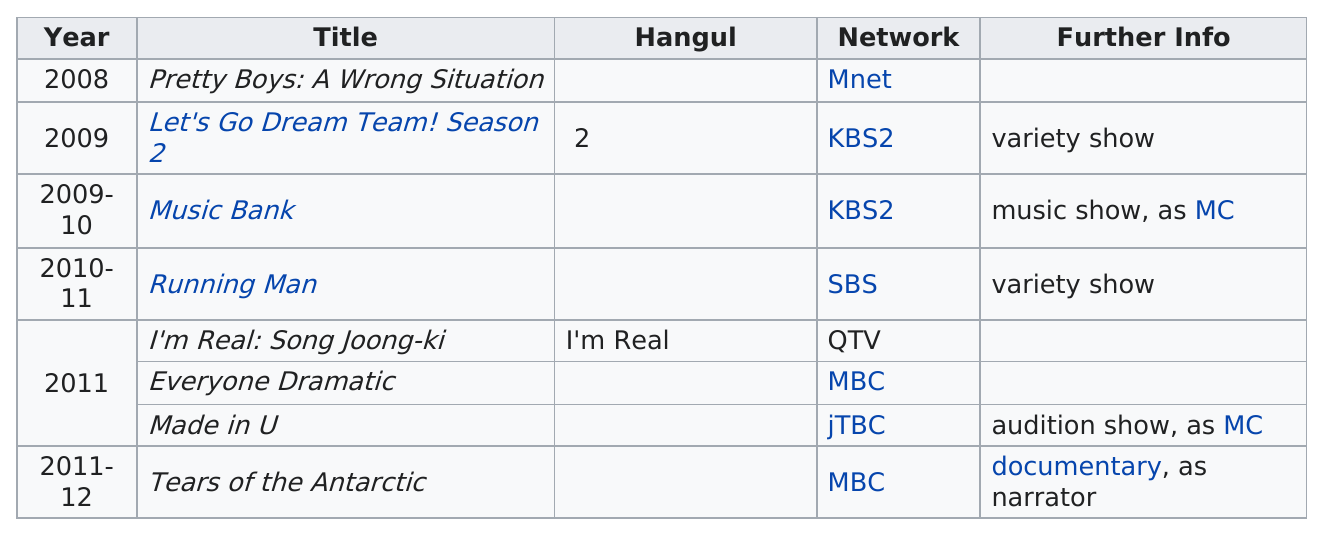Highlight a few significant elements in this photo. I came to be part of the JTBC network. The show that preceded "Music Bank" in 2009 was "Let's Go Dream Team! Season 2. He was in the show 'Music Bank' before appearing on 'Running Man.' Before the title 'Music Bank,' there is a title called 'Let's Go Dream Team! Season 2.' The title following 'Let's Go Dream Team! Season 2' is 'Music Bank..'. 